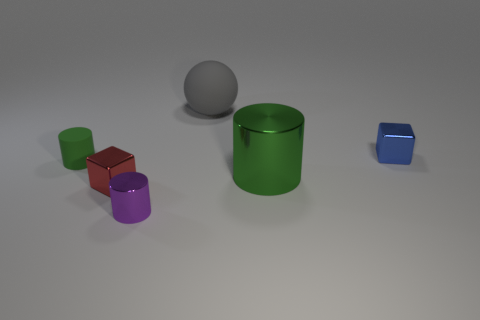Is there a big gray rubber object to the right of the metallic cylinder that is right of the tiny metal cylinder?
Make the answer very short. No. How many other things are there of the same color as the tiny matte thing?
Your answer should be compact. 1. There is a metallic cube on the right side of the green metal cylinder; is it the same size as the matte thing that is in front of the gray rubber ball?
Provide a short and direct response. Yes. There is a metal block that is behind the green cylinder right of the purple thing; what is its size?
Offer a very short reply. Small. What is the material of the tiny object that is in front of the small green matte object and to the right of the red thing?
Offer a terse response. Metal. The big ball is what color?
Offer a terse response. Gray. There is a large object that is in front of the small rubber object; what shape is it?
Keep it short and to the point. Cylinder. Are there any green metallic cylinders in front of the large green cylinder that is behind the small block left of the small blue thing?
Your answer should be very brief. No. Is there any other thing that has the same shape as the large gray rubber thing?
Your response must be concise. No. Is there a large gray matte cube?
Give a very brief answer. No. 